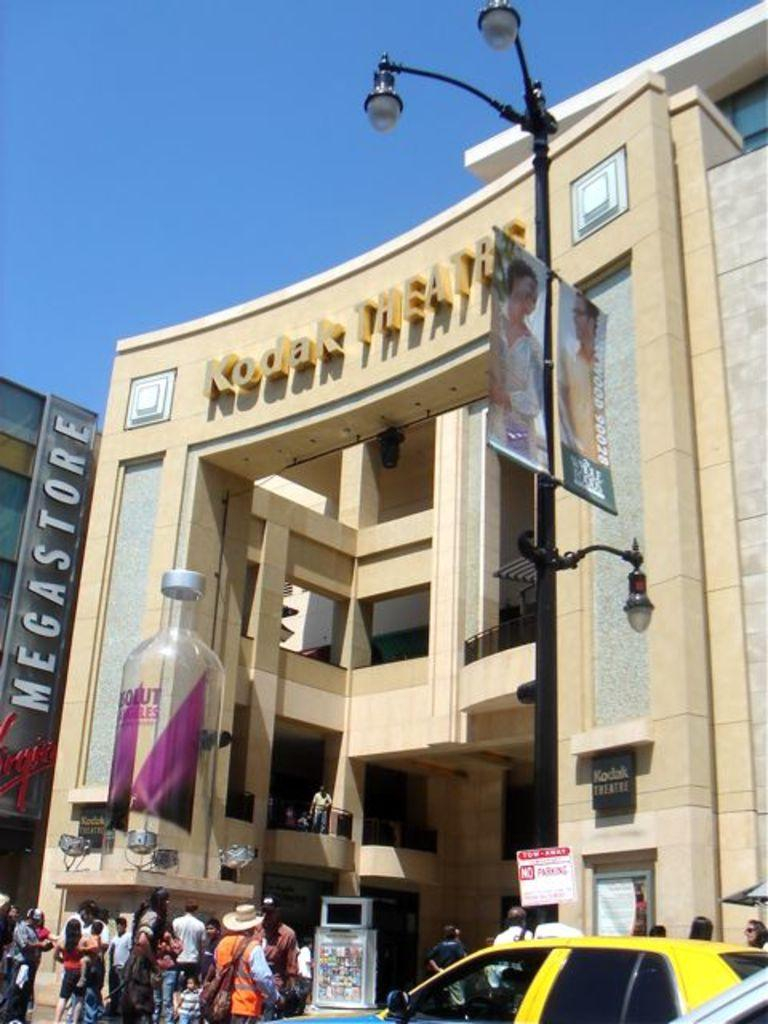<image>
Render a clear and concise summary of the photo. a building with the word Kodak at the top 